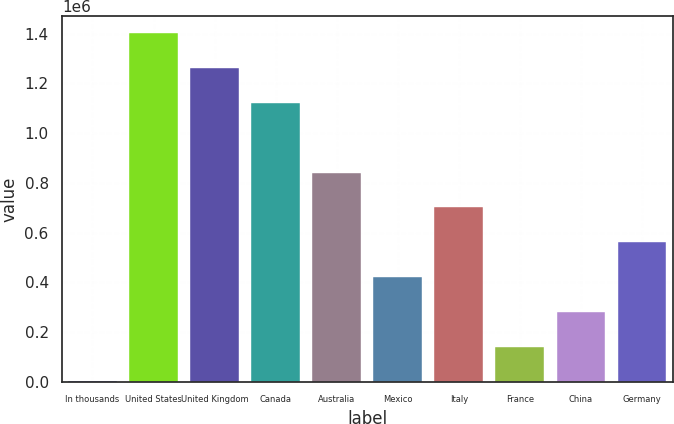Convert chart. <chart><loc_0><loc_0><loc_500><loc_500><bar_chart><fcel>In thousands<fcel>United States<fcel>United Kingdom<fcel>Canada<fcel>Australia<fcel>Mexico<fcel>Italy<fcel>France<fcel>China<fcel>Germany<nl><fcel>2009<fcel>1.40162e+06<fcel>1.26166e+06<fcel>1.12169e+06<fcel>841773<fcel>421891<fcel>701812<fcel>141970<fcel>281930<fcel>561852<nl></chart> 